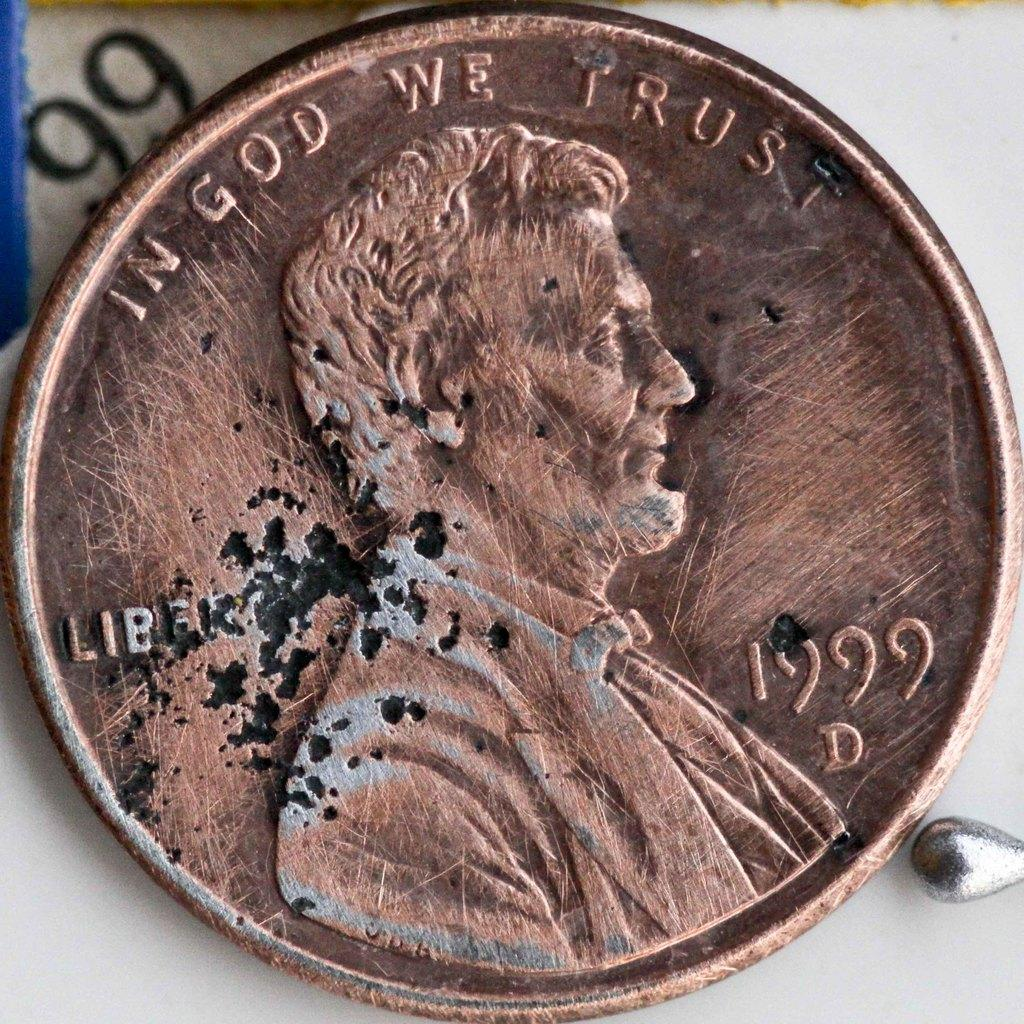Provide a one-sentence caption for the provided image. In God we trust brown penny from 1999. 